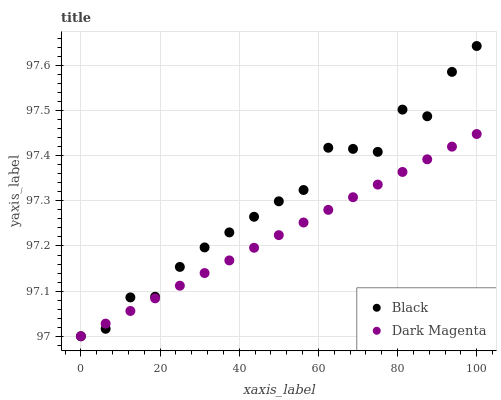Does Dark Magenta have the minimum area under the curve?
Answer yes or no. Yes. Does Black have the maximum area under the curve?
Answer yes or no. Yes. Does Dark Magenta have the maximum area under the curve?
Answer yes or no. No. Is Dark Magenta the smoothest?
Answer yes or no. Yes. Is Black the roughest?
Answer yes or no. Yes. Is Dark Magenta the roughest?
Answer yes or no. No. Does Black have the lowest value?
Answer yes or no. Yes. Does Black have the highest value?
Answer yes or no. Yes. Does Dark Magenta have the highest value?
Answer yes or no. No. Does Dark Magenta intersect Black?
Answer yes or no. Yes. Is Dark Magenta less than Black?
Answer yes or no. No. Is Dark Magenta greater than Black?
Answer yes or no. No. 